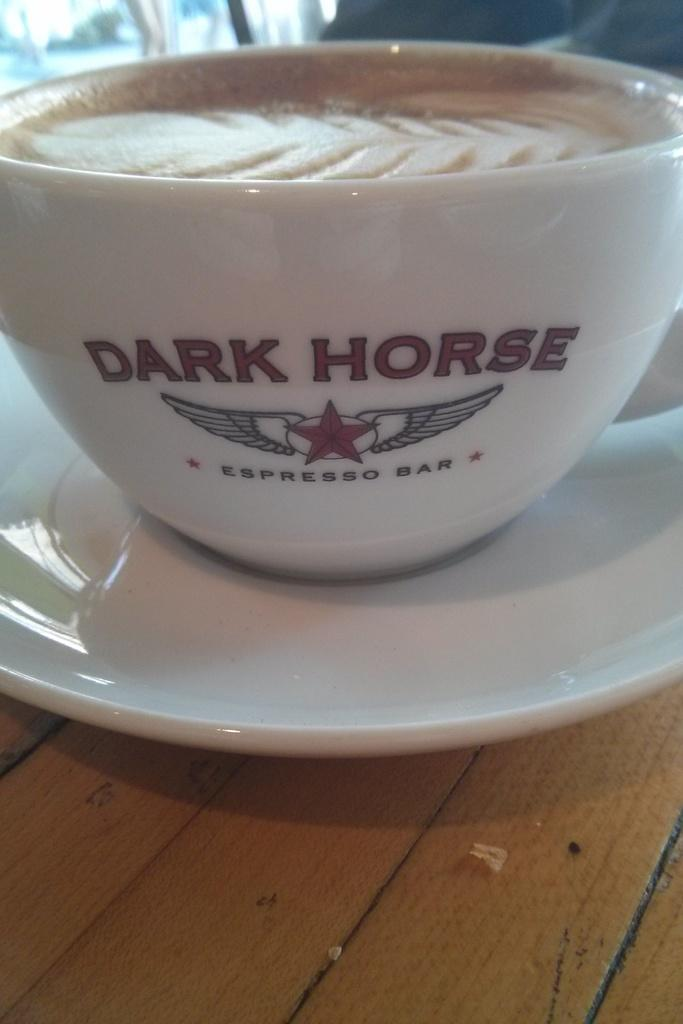What is present on the brown surface in the image? There is a cup and a saucer in the image. What color are the cup and saucer? The cup and saucer are white in color. Are the cup and saucer on the same surface? Yes, the cup and saucer are on the same brown surface. How many birds are sitting on the tooth in the image? There are no birds or teeth present in the image; it only features a cup and saucer on a brown surface. 